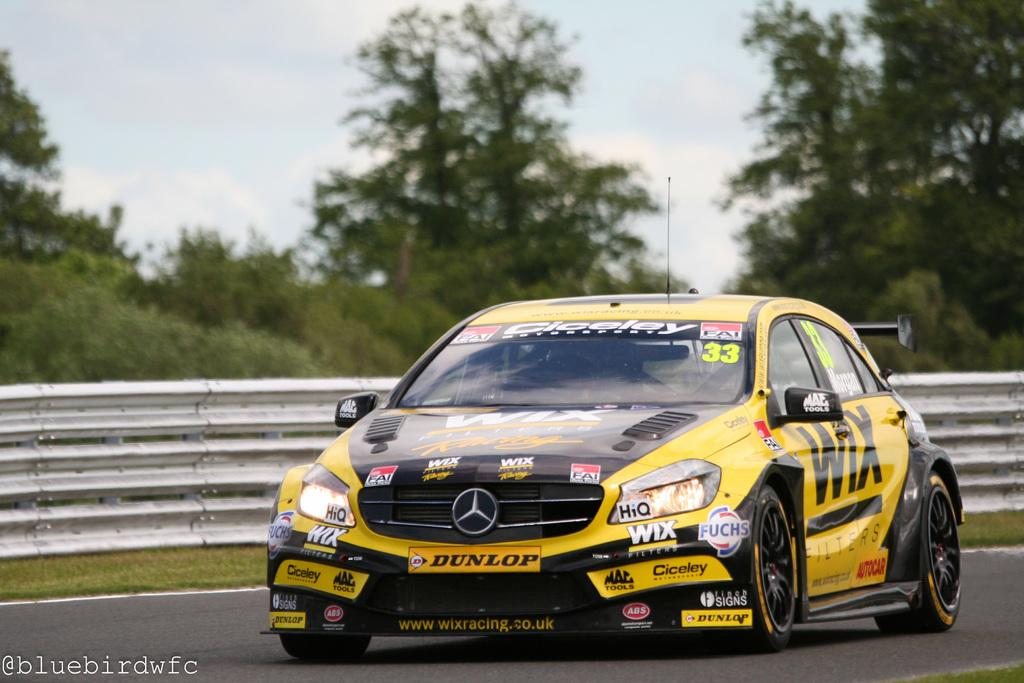<image>
Provide a brief description of the given image. A yellow and black Mercedes sports car that says Cicele on the windshield is going down a race track. 